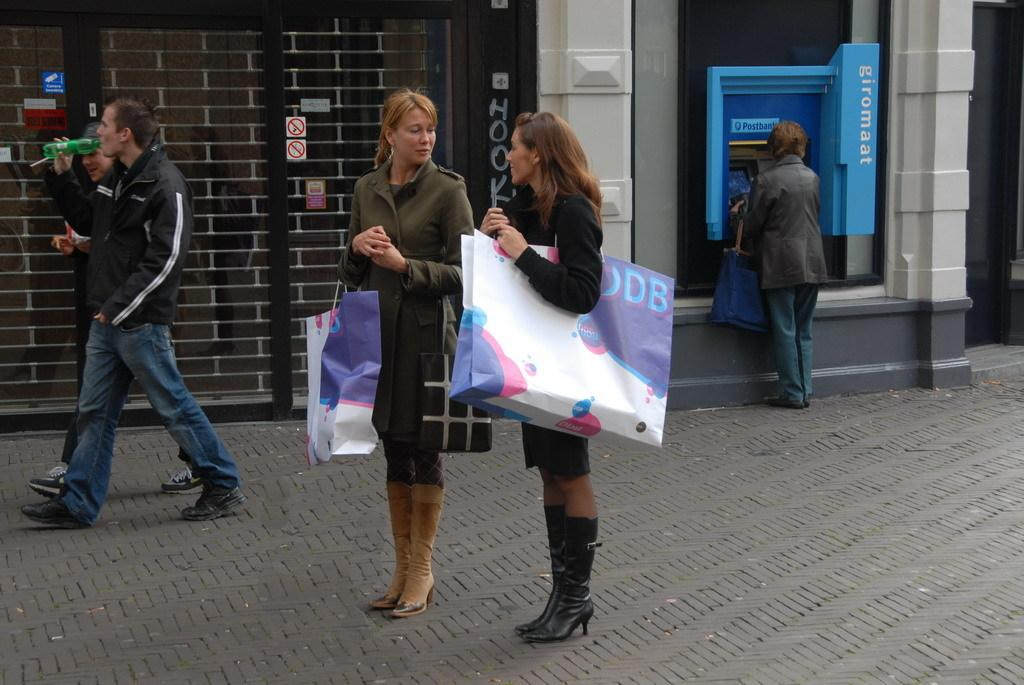Who can be seen in the image? There are people in the image. What are some of the people holding? Some people are holding bags. What are the people in the image doing? Some people are walking. What can be seen in the background of the image? There is a wall visible in the background, as well as a blue color box and other objects. What type of receipt can be seen on the dinner table in the image? There is no dinner table or receipt present in the image. 